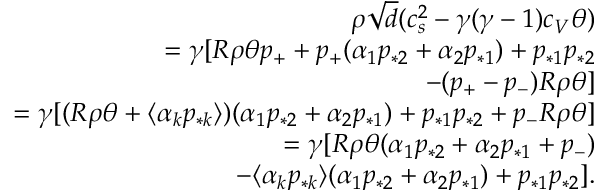<formula> <loc_0><loc_0><loc_500><loc_500>\begin{array} { r } { \rho \sqrt { d } ( c _ { s } ^ { 2 } - \gamma ( \gamma - 1 ) c _ { V } \theta ) } \\ { = \gamma [ R \rho \theta p _ { + } + p _ { + } ( \alpha _ { 1 } p _ { * 2 } + \alpha _ { 2 } p _ { * 1 } ) + p _ { * 1 } p _ { * 2 } } \\ { - ( p _ { + } - p _ { - } ) R \rho \theta ] } \\ { = \gamma [ ( R \rho \theta + \langle \alpha _ { k } p _ { * k } \rangle ) ( \alpha _ { 1 } p _ { * 2 } + \alpha _ { 2 } p _ { * 1 } ) + p _ { * 1 } p _ { * 2 } + p _ { - } R \rho \theta ] } \\ { = \gamma [ R \rho \theta ( \alpha _ { 1 } p _ { * 2 } + \alpha _ { 2 } p _ { * 1 } + p _ { - } ) } \\ { - \langle \alpha _ { k } p _ { * k } \rangle ( \alpha _ { 1 } p _ { * 2 } + \alpha _ { 2 } p _ { * 1 } ) + p _ { * 1 } p _ { * 2 } ] . } \end{array}</formula> 